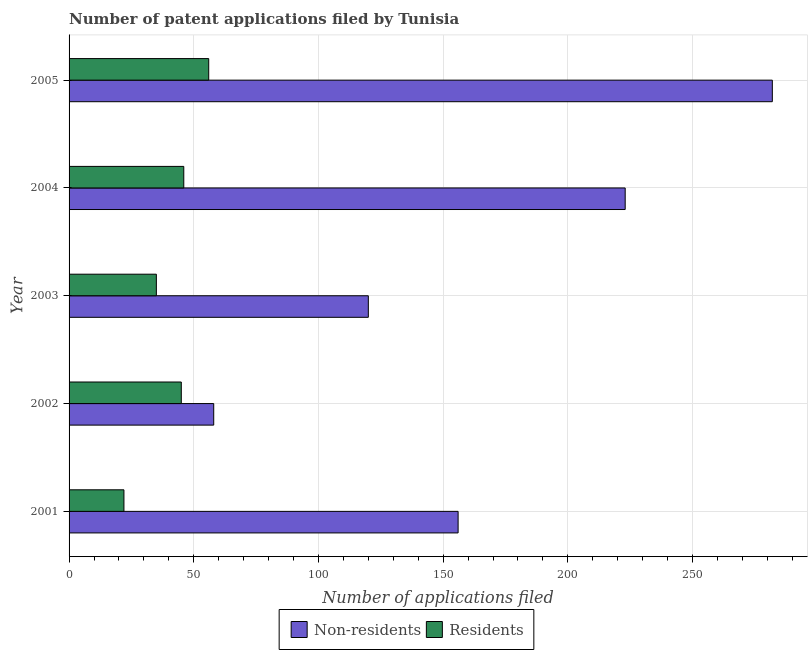Are the number of bars on each tick of the Y-axis equal?
Keep it short and to the point. Yes. What is the number of patent applications by non residents in 2004?
Provide a short and direct response. 223. Across all years, what is the maximum number of patent applications by residents?
Ensure brevity in your answer.  56. Across all years, what is the minimum number of patent applications by non residents?
Your response must be concise. 58. In which year was the number of patent applications by residents minimum?
Your answer should be very brief. 2001. What is the total number of patent applications by residents in the graph?
Your answer should be compact. 204. What is the difference between the number of patent applications by non residents in 2003 and that in 2004?
Your answer should be compact. -103. What is the difference between the number of patent applications by residents in 2001 and the number of patent applications by non residents in 2003?
Your answer should be compact. -98. What is the average number of patent applications by residents per year?
Your answer should be very brief. 40.8. In the year 2003, what is the difference between the number of patent applications by non residents and number of patent applications by residents?
Keep it short and to the point. 85. In how many years, is the number of patent applications by residents greater than 100 ?
Provide a short and direct response. 0. What is the ratio of the number of patent applications by non residents in 2001 to that in 2002?
Provide a succinct answer. 2.69. What is the difference between the highest and the second highest number of patent applications by residents?
Your answer should be very brief. 10. What is the difference between the highest and the lowest number of patent applications by residents?
Ensure brevity in your answer.  34. Is the sum of the number of patent applications by residents in 2001 and 2003 greater than the maximum number of patent applications by non residents across all years?
Your answer should be very brief. No. What does the 2nd bar from the top in 2002 represents?
Offer a terse response. Non-residents. What does the 1st bar from the bottom in 2004 represents?
Keep it short and to the point. Non-residents. Are all the bars in the graph horizontal?
Provide a short and direct response. Yes. How many years are there in the graph?
Ensure brevity in your answer.  5. What is the difference between two consecutive major ticks on the X-axis?
Your answer should be very brief. 50. Where does the legend appear in the graph?
Provide a short and direct response. Bottom center. What is the title of the graph?
Provide a short and direct response. Number of patent applications filed by Tunisia. What is the label or title of the X-axis?
Provide a short and direct response. Number of applications filed. What is the Number of applications filed of Non-residents in 2001?
Your answer should be compact. 156. What is the Number of applications filed of Non-residents in 2002?
Provide a short and direct response. 58. What is the Number of applications filed in Non-residents in 2003?
Your answer should be very brief. 120. What is the Number of applications filed of Residents in 2003?
Keep it short and to the point. 35. What is the Number of applications filed of Non-residents in 2004?
Give a very brief answer. 223. What is the Number of applications filed in Residents in 2004?
Give a very brief answer. 46. What is the Number of applications filed of Non-residents in 2005?
Your answer should be compact. 282. What is the Number of applications filed in Residents in 2005?
Your response must be concise. 56. Across all years, what is the maximum Number of applications filed in Non-residents?
Your answer should be very brief. 282. Across all years, what is the maximum Number of applications filed of Residents?
Offer a terse response. 56. Across all years, what is the minimum Number of applications filed of Non-residents?
Your answer should be very brief. 58. What is the total Number of applications filed in Non-residents in the graph?
Your response must be concise. 839. What is the total Number of applications filed of Residents in the graph?
Ensure brevity in your answer.  204. What is the difference between the Number of applications filed in Residents in 2001 and that in 2002?
Give a very brief answer. -23. What is the difference between the Number of applications filed of Residents in 2001 and that in 2003?
Offer a terse response. -13. What is the difference between the Number of applications filed of Non-residents in 2001 and that in 2004?
Give a very brief answer. -67. What is the difference between the Number of applications filed in Non-residents in 2001 and that in 2005?
Your response must be concise. -126. What is the difference between the Number of applications filed in Residents in 2001 and that in 2005?
Keep it short and to the point. -34. What is the difference between the Number of applications filed in Non-residents in 2002 and that in 2003?
Provide a succinct answer. -62. What is the difference between the Number of applications filed in Non-residents in 2002 and that in 2004?
Your answer should be very brief. -165. What is the difference between the Number of applications filed in Residents in 2002 and that in 2004?
Offer a very short reply. -1. What is the difference between the Number of applications filed of Non-residents in 2002 and that in 2005?
Your response must be concise. -224. What is the difference between the Number of applications filed of Residents in 2002 and that in 2005?
Your response must be concise. -11. What is the difference between the Number of applications filed in Non-residents in 2003 and that in 2004?
Your response must be concise. -103. What is the difference between the Number of applications filed in Residents in 2003 and that in 2004?
Make the answer very short. -11. What is the difference between the Number of applications filed in Non-residents in 2003 and that in 2005?
Provide a succinct answer. -162. What is the difference between the Number of applications filed in Residents in 2003 and that in 2005?
Your answer should be very brief. -21. What is the difference between the Number of applications filed in Non-residents in 2004 and that in 2005?
Keep it short and to the point. -59. What is the difference between the Number of applications filed of Residents in 2004 and that in 2005?
Your answer should be very brief. -10. What is the difference between the Number of applications filed of Non-residents in 2001 and the Number of applications filed of Residents in 2002?
Provide a succinct answer. 111. What is the difference between the Number of applications filed in Non-residents in 2001 and the Number of applications filed in Residents in 2003?
Give a very brief answer. 121. What is the difference between the Number of applications filed of Non-residents in 2001 and the Number of applications filed of Residents in 2004?
Offer a terse response. 110. What is the difference between the Number of applications filed of Non-residents in 2002 and the Number of applications filed of Residents in 2003?
Your answer should be compact. 23. What is the difference between the Number of applications filed of Non-residents in 2002 and the Number of applications filed of Residents in 2004?
Give a very brief answer. 12. What is the difference between the Number of applications filed of Non-residents in 2002 and the Number of applications filed of Residents in 2005?
Make the answer very short. 2. What is the difference between the Number of applications filed of Non-residents in 2004 and the Number of applications filed of Residents in 2005?
Ensure brevity in your answer.  167. What is the average Number of applications filed in Non-residents per year?
Make the answer very short. 167.8. What is the average Number of applications filed in Residents per year?
Provide a succinct answer. 40.8. In the year 2001, what is the difference between the Number of applications filed of Non-residents and Number of applications filed of Residents?
Offer a terse response. 134. In the year 2002, what is the difference between the Number of applications filed of Non-residents and Number of applications filed of Residents?
Make the answer very short. 13. In the year 2003, what is the difference between the Number of applications filed in Non-residents and Number of applications filed in Residents?
Your answer should be compact. 85. In the year 2004, what is the difference between the Number of applications filed of Non-residents and Number of applications filed of Residents?
Offer a terse response. 177. In the year 2005, what is the difference between the Number of applications filed of Non-residents and Number of applications filed of Residents?
Make the answer very short. 226. What is the ratio of the Number of applications filed in Non-residents in 2001 to that in 2002?
Give a very brief answer. 2.69. What is the ratio of the Number of applications filed of Residents in 2001 to that in 2002?
Provide a short and direct response. 0.49. What is the ratio of the Number of applications filed in Non-residents in 2001 to that in 2003?
Give a very brief answer. 1.3. What is the ratio of the Number of applications filed in Residents in 2001 to that in 2003?
Your answer should be very brief. 0.63. What is the ratio of the Number of applications filed in Non-residents in 2001 to that in 2004?
Ensure brevity in your answer.  0.7. What is the ratio of the Number of applications filed in Residents in 2001 to that in 2004?
Offer a terse response. 0.48. What is the ratio of the Number of applications filed in Non-residents in 2001 to that in 2005?
Your answer should be very brief. 0.55. What is the ratio of the Number of applications filed of Residents in 2001 to that in 2005?
Ensure brevity in your answer.  0.39. What is the ratio of the Number of applications filed of Non-residents in 2002 to that in 2003?
Give a very brief answer. 0.48. What is the ratio of the Number of applications filed of Residents in 2002 to that in 2003?
Your answer should be very brief. 1.29. What is the ratio of the Number of applications filed of Non-residents in 2002 to that in 2004?
Keep it short and to the point. 0.26. What is the ratio of the Number of applications filed in Residents in 2002 to that in 2004?
Give a very brief answer. 0.98. What is the ratio of the Number of applications filed of Non-residents in 2002 to that in 2005?
Your response must be concise. 0.21. What is the ratio of the Number of applications filed of Residents in 2002 to that in 2005?
Make the answer very short. 0.8. What is the ratio of the Number of applications filed in Non-residents in 2003 to that in 2004?
Your answer should be compact. 0.54. What is the ratio of the Number of applications filed in Residents in 2003 to that in 2004?
Your answer should be very brief. 0.76. What is the ratio of the Number of applications filed in Non-residents in 2003 to that in 2005?
Provide a short and direct response. 0.43. What is the ratio of the Number of applications filed of Residents in 2003 to that in 2005?
Offer a terse response. 0.62. What is the ratio of the Number of applications filed in Non-residents in 2004 to that in 2005?
Your answer should be very brief. 0.79. What is the ratio of the Number of applications filed in Residents in 2004 to that in 2005?
Ensure brevity in your answer.  0.82. What is the difference between the highest and the lowest Number of applications filed of Non-residents?
Provide a succinct answer. 224. What is the difference between the highest and the lowest Number of applications filed of Residents?
Offer a very short reply. 34. 